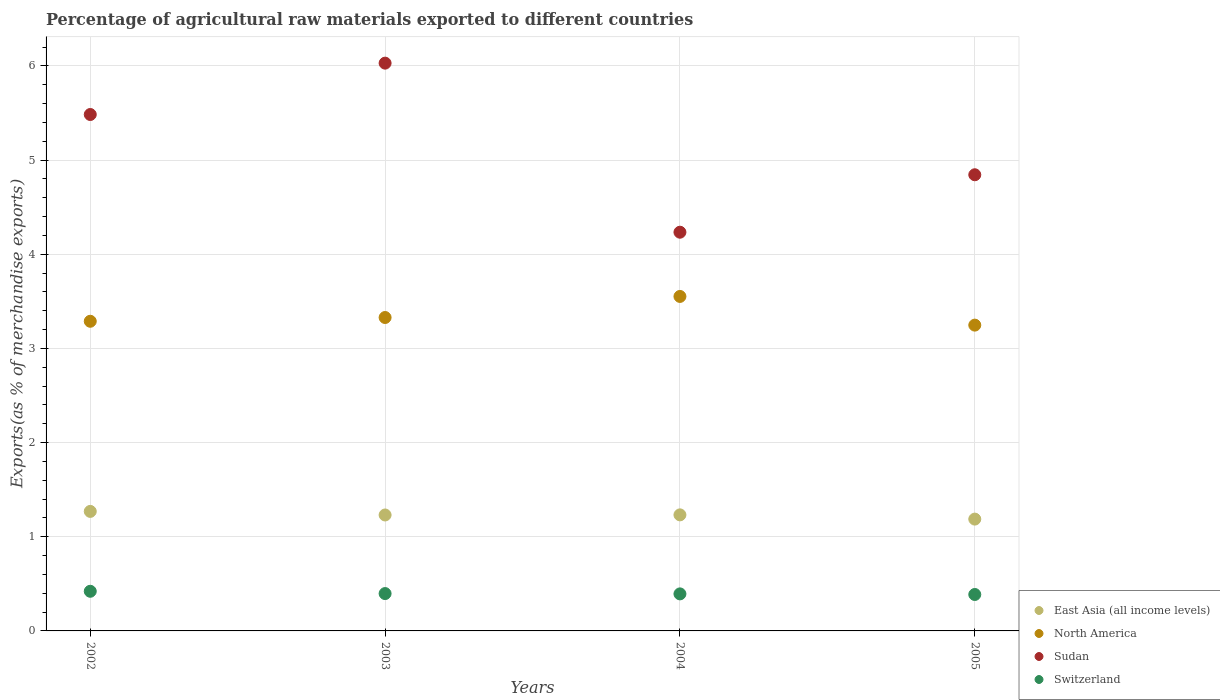What is the percentage of exports to different countries in Switzerland in 2003?
Your answer should be compact. 0.4. Across all years, what is the maximum percentage of exports to different countries in North America?
Your answer should be very brief. 3.55. Across all years, what is the minimum percentage of exports to different countries in Sudan?
Your answer should be very brief. 4.23. In which year was the percentage of exports to different countries in North America minimum?
Make the answer very short. 2005. What is the total percentage of exports to different countries in Sudan in the graph?
Make the answer very short. 20.59. What is the difference between the percentage of exports to different countries in North America in 2004 and that in 2005?
Give a very brief answer. 0.3. What is the difference between the percentage of exports to different countries in Switzerland in 2002 and the percentage of exports to different countries in East Asia (all income levels) in 2005?
Offer a very short reply. -0.77. What is the average percentage of exports to different countries in Sudan per year?
Your answer should be compact. 5.15. In the year 2002, what is the difference between the percentage of exports to different countries in Switzerland and percentage of exports to different countries in Sudan?
Your answer should be compact. -5.06. In how many years, is the percentage of exports to different countries in North America greater than 3.6 %?
Your response must be concise. 0. What is the ratio of the percentage of exports to different countries in Sudan in 2002 to that in 2004?
Provide a succinct answer. 1.3. Is the percentage of exports to different countries in East Asia (all income levels) in 2002 less than that in 2003?
Your answer should be very brief. No. Is the difference between the percentage of exports to different countries in Switzerland in 2002 and 2003 greater than the difference between the percentage of exports to different countries in Sudan in 2002 and 2003?
Offer a very short reply. Yes. What is the difference between the highest and the second highest percentage of exports to different countries in Switzerland?
Your answer should be compact. 0.02. What is the difference between the highest and the lowest percentage of exports to different countries in East Asia (all income levels)?
Your answer should be very brief. 0.08. In how many years, is the percentage of exports to different countries in Sudan greater than the average percentage of exports to different countries in Sudan taken over all years?
Ensure brevity in your answer.  2. Is the sum of the percentage of exports to different countries in Switzerland in 2002 and 2004 greater than the maximum percentage of exports to different countries in East Asia (all income levels) across all years?
Your answer should be very brief. No. Is it the case that in every year, the sum of the percentage of exports to different countries in Sudan and percentage of exports to different countries in Switzerland  is greater than the sum of percentage of exports to different countries in North America and percentage of exports to different countries in East Asia (all income levels)?
Offer a terse response. No. Is it the case that in every year, the sum of the percentage of exports to different countries in Sudan and percentage of exports to different countries in East Asia (all income levels)  is greater than the percentage of exports to different countries in Switzerland?
Your answer should be very brief. Yes. Does the percentage of exports to different countries in North America monotonically increase over the years?
Offer a very short reply. No. Is the percentage of exports to different countries in Switzerland strictly greater than the percentage of exports to different countries in Sudan over the years?
Keep it short and to the point. No. Is the percentage of exports to different countries in East Asia (all income levels) strictly less than the percentage of exports to different countries in North America over the years?
Your answer should be very brief. Yes. How many years are there in the graph?
Your answer should be compact. 4. What is the difference between two consecutive major ticks on the Y-axis?
Make the answer very short. 1. Does the graph contain grids?
Offer a very short reply. Yes. How many legend labels are there?
Ensure brevity in your answer.  4. What is the title of the graph?
Your answer should be very brief. Percentage of agricultural raw materials exported to different countries. What is the label or title of the Y-axis?
Keep it short and to the point. Exports(as % of merchandise exports). What is the Exports(as % of merchandise exports) in East Asia (all income levels) in 2002?
Ensure brevity in your answer.  1.27. What is the Exports(as % of merchandise exports) in North America in 2002?
Keep it short and to the point. 3.29. What is the Exports(as % of merchandise exports) in Sudan in 2002?
Ensure brevity in your answer.  5.48. What is the Exports(as % of merchandise exports) of Switzerland in 2002?
Give a very brief answer. 0.42. What is the Exports(as % of merchandise exports) of East Asia (all income levels) in 2003?
Your response must be concise. 1.23. What is the Exports(as % of merchandise exports) in North America in 2003?
Offer a terse response. 3.33. What is the Exports(as % of merchandise exports) of Sudan in 2003?
Make the answer very short. 6.03. What is the Exports(as % of merchandise exports) of Switzerland in 2003?
Your response must be concise. 0.4. What is the Exports(as % of merchandise exports) of East Asia (all income levels) in 2004?
Ensure brevity in your answer.  1.23. What is the Exports(as % of merchandise exports) of North America in 2004?
Keep it short and to the point. 3.55. What is the Exports(as % of merchandise exports) of Sudan in 2004?
Provide a succinct answer. 4.23. What is the Exports(as % of merchandise exports) in Switzerland in 2004?
Offer a terse response. 0.39. What is the Exports(as % of merchandise exports) in East Asia (all income levels) in 2005?
Provide a succinct answer. 1.19. What is the Exports(as % of merchandise exports) in North America in 2005?
Give a very brief answer. 3.25. What is the Exports(as % of merchandise exports) of Sudan in 2005?
Provide a short and direct response. 4.84. What is the Exports(as % of merchandise exports) of Switzerland in 2005?
Ensure brevity in your answer.  0.39. Across all years, what is the maximum Exports(as % of merchandise exports) in East Asia (all income levels)?
Keep it short and to the point. 1.27. Across all years, what is the maximum Exports(as % of merchandise exports) of North America?
Your response must be concise. 3.55. Across all years, what is the maximum Exports(as % of merchandise exports) in Sudan?
Provide a succinct answer. 6.03. Across all years, what is the maximum Exports(as % of merchandise exports) in Switzerland?
Your answer should be very brief. 0.42. Across all years, what is the minimum Exports(as % of merchandise exports) of East Asia (all income levels)?
Keep it short and to the point. 1.19. Across all years, what is the minimum Exports(as % of merchandise exports) in North America?
Your answer should be compact. 3.25. Across all years, what is the minimum Exports(as % of merchandise exports) of Sudan?
Your answer should be compact. 4.23. Across all years, what is the minimum Exports(as % of merchandise exports) of Switzerland?
Keep it short and to the point. 0.39. What is the total Exports(as % of merchandise exports) of East Asia (all income levels) in the graph?
Your response must be concise. 4.92. What is the total Exports(as % of merchandise exports) in North America in the graph?
Ensure brevity in your answer.  13.42. What is the total Exports(as % of merchandise exports) of Sudan in the graph?
Provide a short and direct response. 20.59. What is the total Exports(as % of merchandise exports) of Switzerland in the graph?
Offer a terse response. 1.6. What is the difference between the Exports(as % of merchandise exports) of East Asia (all income levels) in 2002 and that in 2003?
Your response must be concise. 0.04. What is the difference between the Exports(as % of merchandise exports) in North America in 2002 and that in 2003?
Give a very brief answer. -0.04. What is the difference between the Exports(as % of merchandise exports) in Sudan in 2002 and that in 2003?
Give a very brief answer. -0.55. What is the difference between the Exports(as % of merchandise exports) in Switzerland in 2002 and that in 2003?
Your answer should be very brief. 0.02. What is the difference between the Exports(as % of merchandise exports) in East Asia (all income levels) in 2002 and that in 2004?
Provide a short and direct response. 0.04. What is the difference between the Exports(as % of merchandise exports) in North America in 2002 and that in 2004?
Your answer should be compact. -0.26. What is the difference between the Exports(as % of merchandise exports) in Sudan in 2002 and that in 2004?
Keep it short and to the point. 1.25. What is the difference between the Exports(as % of merchandise exports) in Switzerland in 2002 and that in 2004?
Keep it short and to the point. 0.03. What is the difference between the Exports(as % of merchandise exports) of East Asia (all income levels) in 2002 and that in 2005?
Your response must be concise. 0.08. What is the difference between the Exports(as % of merchandise exports) in North America in 2002 and that in 2005?
Provide a succinct answer. 0.04. What is the difference between the Exports(as % of merchandise exports) of Sudan in 2002 and that in 2005?
Ensure brevity in your answer.  0.64. What is the difference between the Exports(as % of merchandise exports) in Switzerland in 2002 and that in 2005?
Your answer should be compact. 0.03. What is the difference between the Exports(as % of merchandise exports) of East Asia (all income levels) in 2003 and that in 2004?
Offer a very short reply. -0. What is the difference between the Exports(as % of merchandise exports) of North America in 2003 and that in 2004?
Give a very brief answer. -0.22. What is the difference between the Exports(as % of merchandise exports) of Sudan in 2003 and that in 2004?
Offer a very short reply. 1.8. What is the difference between the Exports(as % of merchandise exports) in Switzerland in 2003 and that in 2004?
Provide a succinct answer. 0. What is the difference between the Exports(as % of merchandise exports) in East Asia (all income levels) in 2003 and that in 2005?
Your answer should be compact. 0.04. What is the difference between the Exports(as % of merchandise exports) in North America in 2003 and that in 2005?
Keep it short and to the point. 0.08. What is the difference between the Exports(as % of merchandise exports) in Sudan in 2003 and that in 2005?
Ensure brevity in your answer.  1.19. What is the difference between the Exports(as % of merchandise exports) of Switzerland in 2003 and that in 2005?
Ensure brevity in your answer.  0.01. What is the difference between the Exports(as % of merchandise exports) in East Asia (all income levels) in 2004 and that in 2005?
Keep it short and to the point. 0.04. What is the difference between the Exports(as % of merchandise exports) of North America in 2004 and that in 2005?
Ensure brevity in your answer.  0.3. What is the difference between the Exports(as % of merchandise exports) of Sudan in 2004 and that in 2005?
Your answer should be compact. -0.61. What is the difference between the Exports(as % of merchandise exports) of Switzerland in 2004 and that in 2005?
Ensure brevity in your answer.  0.01. What is the difference between the Exports(as % of merchandise exports) in East Asia (all income levels) in 2002 and the Exports(as % of merchandise exports) in North America in 2003?
Give a very brief answer. -2.06. What is the difference between the Exports(as % of merchandise exports) of East Asia (all income levels) in 2002 and the Exports(as % of merchandise exports) of Sudan in 2003?
Your answer should be very brief. -4.76. What is the difference between the Exports(as % of merchandise exports) of East Asia (all income levels) in 2002 and the Exports(as % of merchandise exports) of Switzerland in 2003?
Your response must be concise. 0.87. What is the difference between the Exports(as % of merchandise exports) of North America in 2002 and the Exports(as % of merchandise exports) of Sudan in 2003?
Make the answer very short. -2.74. What is the difference between the Exports(as % of merchandise exports) in North America in 2002 and the Exports(as % of merchandise exports) in Switzerland in 2003?
Ensure brevity in your answer.  2.89. What is the difference between the Exports(as % of merchandise exports) in Sudan in 2002 and the Exports(as % of merchandise exports) in Switzerland in 2003?
Provide a short and direct response. 5.09. What is the difference between the Exports(as % of merchandise exports) of East Asia (all income levels) in 2002 and the Exports(as % of merchandise exports) of North America in 2004?
Offer a very short reply. -2.28. What is the difference between the Exports(as % of merchandise exports) in East Asia (all income levels) in 2002 and the Exports(as % of merchandise exports) in Sudan in 2004?
Keep it short and to the point. -2.97. What is the difference between the Exports(as % of merchandise exports) of East Asia (all income levels) in 2002 and the Exports(as % of merchandise exports) of Switzerland in 2004?
Offer a terse response. 0.88. What is the difference between the Exports(as % of merchandise exports) of North America in 2002 and the Exports(as % of merchandise exports) of Sudan in 2004?
Your answer should be compact. -0.95. What is the difference between the Exports(as % of merchandise exports) of North America in 2002 and the Exports(as % of merchandise exports) of Switzerland in 2004?
Your answer should be compact. 2.9. What is the difference between the Exports(as % of merchandise exports) in Sudan in 2002 and the Exports(as % of merchandise exports) in Switzerland in 2004?
Give a very brief answer. 5.09. What is the difference between the Exports(as % of merchandise exports) of East Asia (all income levels) in 2002 and the Exports(as % of merchandise exports) of North America in 2005?
Provide a short and direct response. -1.98. What is the difference between the Exports(as % of merchandise exports) of East Asia (all income levels) in 2002 and the Exports(as % of merchandise exports) of Sudan in 2005?
Make the answer very short. -3.58. What is the difference between the Exports(as % of merchandise exports) of East Asia (all income levels) in 2002 and the Exports(as % of merchandise exports) of Switzerland in 2005?
Keep it short and to the point. 0.88. What is the difference between the Exports(as % of merchandise exports) in North America in 2002 and the Exports(as % of merchandise exports) in Sudan in 2005?
Ensure brevity in your answer.  -1.56. What is the difference between the Exports(as % of merchandise exports) of North America in 2002 and the Exports(as % of merchandise exports) of Switzerland in 2005?
Offer a terse response. 2.9. What is the difference between the Exports(as % of merchandise exports) of Sudan in 2002 and the Exports(as % of merchandise exports) of Switzerland in 2005?
Give a very brief answer. 5.1. What is the difference between the Exports(as % of merchandise exports) of East Asia (all income levels) in 2003 and the Exports(as % of merchandise exports) of North America in 2004?
Offer a terse response. -2.32. What is the difference between the Exports(as % of merchandise exports) in East Asia (all income levels) in 2003 and the Exports(as % of merchandise exports) in Sudan in 2004?
Provide a succinct answer. -3. What is the difference between the Exports(as % of merchandise exports) in East Asia (all income levels) in 2003 and the Exports(as % of merchandise exports) in Switzerland in 2004?
Make the answer very short. 0.84. What is the difference between the Exports(as % of merchandise exports) in North America in 2003 and the Exports(as % of merchandise exports) in Sudan in 2004?
Make the answer very short. -0.91. What is the difference between the Exports(as % of merchandise exports) in North America in 2003 and the Exports(as % of merchandise exports) in Switzerland in 2004?
Make the answer very short. 2.94. What is the difference between the Exports(as % of merchandise exports) of Sudan in 2003 and the Exports(as % of merchandise exports) of Switzerland in 2004?
Your response must be concise. 5.64. What is the difference between the Exports(as % of merchandise exports) of East Asia (all income levels) in 2003 and the Exports(as % of merchandise exports) of North America in 2005?
Provide a succinct answer. -2.02. What is the difference between the Exports(as % of merchandise exports) in East Asia (all income levels) in 2003 and the Exports(as % of merchandise exports) in Sudan in 2005?
Keep it short and to the point. -3.61. What is the difference between the Exports(as % of merchandise exports) of East Asia (all income levels) in 2003 and the Exports(as % of merchandise exports) of Switzerland in 2005?
Give a very brief answer. 0.84. What is the difference between the Exports(as % of merchandise exports) of North America in 2003 and the Exports(as % of merchandise exports) of Sudan in 2005?
Offer a terse response. -1.52. What is the difference between the Exports(as % of merchandise exports) in North America in 2003 and the Exports(as % of merchandise exports) in Switzerland in 2005?
Give a very brief answer. 2.94. What is the difference between the Exports(as % of merchandise exports) in Sudan in 2003 and the Exports(as % of merchandise exports) in Switzerland in 2005?
Your answer should be very brief. 5.64. What is the difference between the Exports(as % of merchandise exports) of East Asia (all income levels) in 2004 and the Exports(as % of merchandise exports) of North America in 2005?
Your response must be concise. -2.02. What is the difference between the Exports(as % of merchandise exports) of East Asia (all income levels) in 2004 and the Exports(as % of merchandise exports) of Sudan in 2005?
Your answer should be compact. -3.61. What is the difference between the Exports(as % of merchandise exports) in East Asia (all income levels) in 2004 and the Exports(as % of merchandise exports) in Switzerland in 2005?
Offer a terse response. 0.85. What is the difference between the Exports(as % of merchandise exports) in North America in 2004 and the Exports(as % of merchandise exports) in Sudan in 2005?
Give a very brief answer. -1.29. What is the difference between the Exports(as % of merchandise exports) in North America in 2004 and the Exports(as % of merchandise exports) in Switzerland in 2005?
Your response must be concise. 3.17. What is the difference between the Exports(as % of merchandise exports) in Sudan in 2004 and the Exports(as % of merchandise exports) in Switzerland in 2005?
Ensure brevity in your answer.  3.85. What is the average Exports(as % of merchandise exports) in East Asia (all income levels) per year?
Ensure brevity in your answer.  1.23. What is the average Exports(as % of merchandise exports) of North America per year?
Provide a succinct answer. 3.35. What is the average Exports(as % of merchandise exports) in Sudan per year?
Offer a terse response. 5.15. What is the average Exports(as % of merchandise exports) of Switzerland per year?
Make the answer very short. 0.4. In the year 2002, what is the difference between the Exports(as % of merchandise exports) in East Asia (all income levels) and Exports(as % of merchandise exports) in North America?
Offer a very short reply. -2.02. In the year 2002, what is the difference between the Exports(as % of merchandise exports) in East Asia (all income levels) and Exports(as % of merchandise exports) in Sudan?
Offer a terse response. -4.22. In the year 2002, what is the difference between the Exports(as % of merchandise exports) of East Asia (all income levels) and Exports(as % of merchandise exports) of Switzerland?
Your answer should be very brief. 0.85. In the year 2002, what is the difference between the Exports(as % of merchandise exports) in North America and Exports(as % of merchandise exports) in Sudan?
Provide a succinct answer. -2.2. In the year 2002, what is the difference between the Exports(as % of merchandise exports) of North America and Exports(as % of merchandise exports) of Switzerland?
Provide a short and direct response. 2.87. In the year 2002, what is the difference between the Exports(as % of merchandise exports) of Sudan and Exports(as % of merchandise exports) of Switzerland?
Your answer should be compact. 5.06. In the year 2003, what is the difference between the Exports(as % of merchandise exports) of East Asia (all income levels) and Exports(as % of merchandise exports) of North America?
Give a very brief answer. -2.1. In the year 2003, what is the difference between the Exports(as % of merchandise exports) of East Asia (all income levels) and Exports(as % of merchandise exports) of Sudan?
Offer a terse response. -4.8. In the year 2003, what is the difference between the Exports(as % of merchandise exports) of East Asia (all income levels) and Exports(as % of merchandise exports) of Switzerland?
Your response must be concise. 0.83. In the year 2003, what is the difference between the Exports(as % of merchandise exports) of North America and Exports(as % of merchandise exports) of Sudan?
Give a very brief answer. -2.7. In the year 2003, what is the difference between the Exports(as % of merchandise exports) of North America and Exports(as % of merchandise exports) of Switzerland?
Provide a succinct answer. 2.93. In the year 2003, what is the difference between the Exports(as % of merchandise exports) in Sudan and Exports(as % of merchandise exports) in Switzerland?
Offer a very short reply. 5.63. In the year 2004, what is the difference between the Exports(as % of merchandise exports) in East Asia (all income levels) and Exports(as % of merchandise exports) in North America?
Offer a very short reply. -2.32. In the year 2004, what is the difference between the Exports(as % of merchandise exports) in East Asia (all income levels) and Exports(as % of merchandise exports) in Sudan?
Offer a very short reply. -3. In the year 2004, what is the difference between the Exports(as % of merchandise exports) in East Asia (all income levels) and Exports(as % of merchandise exports) in Switzerland?
Provide a short and direct response. 0.84. In the year 2004, what is the difference between the Exports(as % of merchandise exports) of North America and Exports(as % of merchandise exports) of Sudan?
Ensure brevity in your answer.  -0.68. In the year 2004, what is the difference between the Exports(as % of merchandise exports) in North America and Exports(as % of merchandise exports) in Switzerland?
Provide a short and direct response. 3.16. In the year 2004, what is the difference between the Exports(as % of merchandise exports) of Sudan and Exports(as % of merchandise exports) of Switzerland?
Offer a terse response. 3.84. In the year 2005, what is the difference between the Exports(as % of merchandise exports) of East Asia (all income levels) and Exports(as % of merchandise exports) of North America?
Your response must be concise. -2.06. In the year 2005, what is the difference between the Exports(as % of merchandise exports) of East Asia (all income levels) and Exports(as % of merchandise exports) of Sudan?
Ensure brevity in your answer.  -3.66. In the year 2005, what is the difference between the Exports(as % of merchandise exports) of East Asia (all income levels) and Exports(as % of merchandise exports) of Switzerland?
Offer a very short reply. 0.8. In the year 2005, what is the difference between the Exports(as % of merchandise exports) of North America and Exports(as % of merchandise exports) of Sudan?
Keep it short and to the point. -1.6. In the year 2005, what is the difference between the Exports(as % of merchandise exports) of North America and Exports(as % of merchandise exports) of Switzerland?
Keep it short and to the point. 2.86. In the year 2005, what is the difference between the Exports(as % of merchandise exports) of Sudan and Exports(as % of merchandise exports) of Switzerland?
Your answer should be very brief. 4.46. What is the ratio of the Exports(as % of merchandise exports) of East Asia (all income levels) in 2002 to that in 2003?
Offer a very short reply. 1.03. What is the ratio of the Exports(as % of merchandise exports) in Sudan in 2002 to that in 2003?
Your response must be concise. 0.91. What is the ratio of the Exports(as % of merchandise exports) of Switzerland in 2002 to that in 2003?
Your answer should be very brief. 1.06. What is the ratio of the Exports(as % of merchandise exports) of East Asia (all income levels) in 2002 to that in 2004?
Your response must be concise. 1.03. What is the ratio of the Exports(as % of merchandise exports) of North America in 2002 to that in 2004?
Give a very brief answer. 0.93. What is the ratio of the Exports(as % of merchandise exports) in Sudan in 2002 to that in 2004?
Offer a very short reply. 1.3. What is the ratio of the Exports(as % of merchandise exports) of Switzerland in 2002 to that in 2004?
Your answer should be compact. 1.07. What is the ratio of the Exports(as % of merchandise exports) of East Asia (all income levels) in 2002 to that in 2005?
Your answer should be very brief. 1.07. What is the ratio of the Exports(as % of merchandise exports) in North America in 2002 to that in 2005?
Provide a short and direct response. 1.01. What is the ratio of the Exports(as % of merchandise exports) in Sudan in 2002 to that in 2005?
Provide a succinct answer. 1.13. What is the ratio of the Exports(as % of merchandise exports) in Switzerland in 2002 to that in 2005?
Make the answer very short. 1.09. What is the ratio of the Exports(as % of merchandise exports) in North America in 2003 to that in 2004?
Ensure brevity in your answer.  0.94. What is the ratio of the Exports(as % of merchandise exports) in Sudan in 2003 to that in 2004?
Offer a terse response. 1.42. What is the ratio of the Exports(as % of merchandise exports) of Switzerland in 2003 to that in 2004?
Your answer should be compact. 1.01. What is the ratio of the Exports(as % of merchandise exports) in East Asia (all income levels) in 2003 to that in 2005?
Your response must be concise. 1.04. What is the ratio of the Exports(as % of merchandise exports) in North America in 2003 to that in 2005?
Keep it short and to the point. 1.02. What is the ratio of the Exports(as % of merchandise exports) of Sudan in 2003 to that in 2005?
Keep it short and to the point. 1.24. What is the ratio of the Exports(as % of merchandise exports) in Switzerland in 2003 to that in 2005?
Offer a terse response. 1.03. What is the ratio of the Exports(as % of merchandise exports) in East Asia (all income levels) in 2004 to that in 2005?
Your response must be concise. 1.04. What is the ratio of the Exports(as % of merchandise exports) in North America in 2004 to that in 2005?
Your answer should be very brief. 1.09. What is the ratio of the Exports(as % of merchandise exports) of Sudan in 2004 to that in 2005?
Your answer should be compact. 0.87. What is the ratio of the Exports(as % of merchandise exports) of Switzerland in 2004 to that in 2005?
Provide a short and direct response. 1.02. What is the difference between the highest and the second highest Exports(as % of merchandise exports) of East Asia (all income levels)?
Provide a succinct answer. 0.04. What is the difference between the highest and the second highest Exports(as % of merchandise exports) in North America?
Make the answer very short. 0.22. What is the difference between the highest and the second highest Exports(as % of merchandise exports) of Sudan?
Ensure brevity in your answer.  0.55. What is the difference between the highest and the second highest Exports(as % of merchandise exports) in Switzerland?
Make the answer very short. 0.02. What is the difference between the highest and the lowest Exports(as % of merchandise exports) of East Asia (all income levels)?
Provide a succinct answer. 0.08. What is the difference between the highest and the lowest Exports(as % of merchandise exports) in North America?
Make the answer very short. 0.3. What is the difference between the highest and the lowest Exports(as % of merchandise exports) in Sudan?
Ensure brevity in your answer.  1.8. What is the difference between the highest and the lowest Exports(as % of merchandise exports) of Switzerland?
Offer a very short reply. 0.03. 